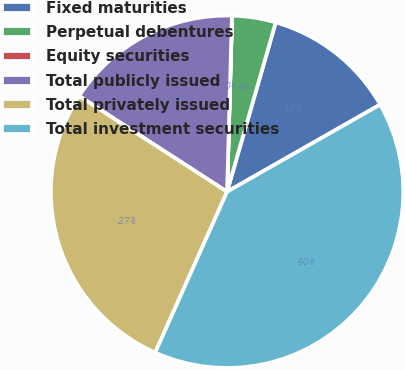<chart> <loc_0><loc_0><loc_500><loc_500><pie_chart><fcel>Fixed maturities<fcel>Perpetual debentures<fcel>Equity securities<fcel>Total publicly issued<fcel>Total privately issued<fcel>Total investment securities<nl><fcel>12.31%<fcel>4.0%<fcel>0.01%<fcel>16.3%<fcel>27.45%<fcel>39.92%<nl></chart> 